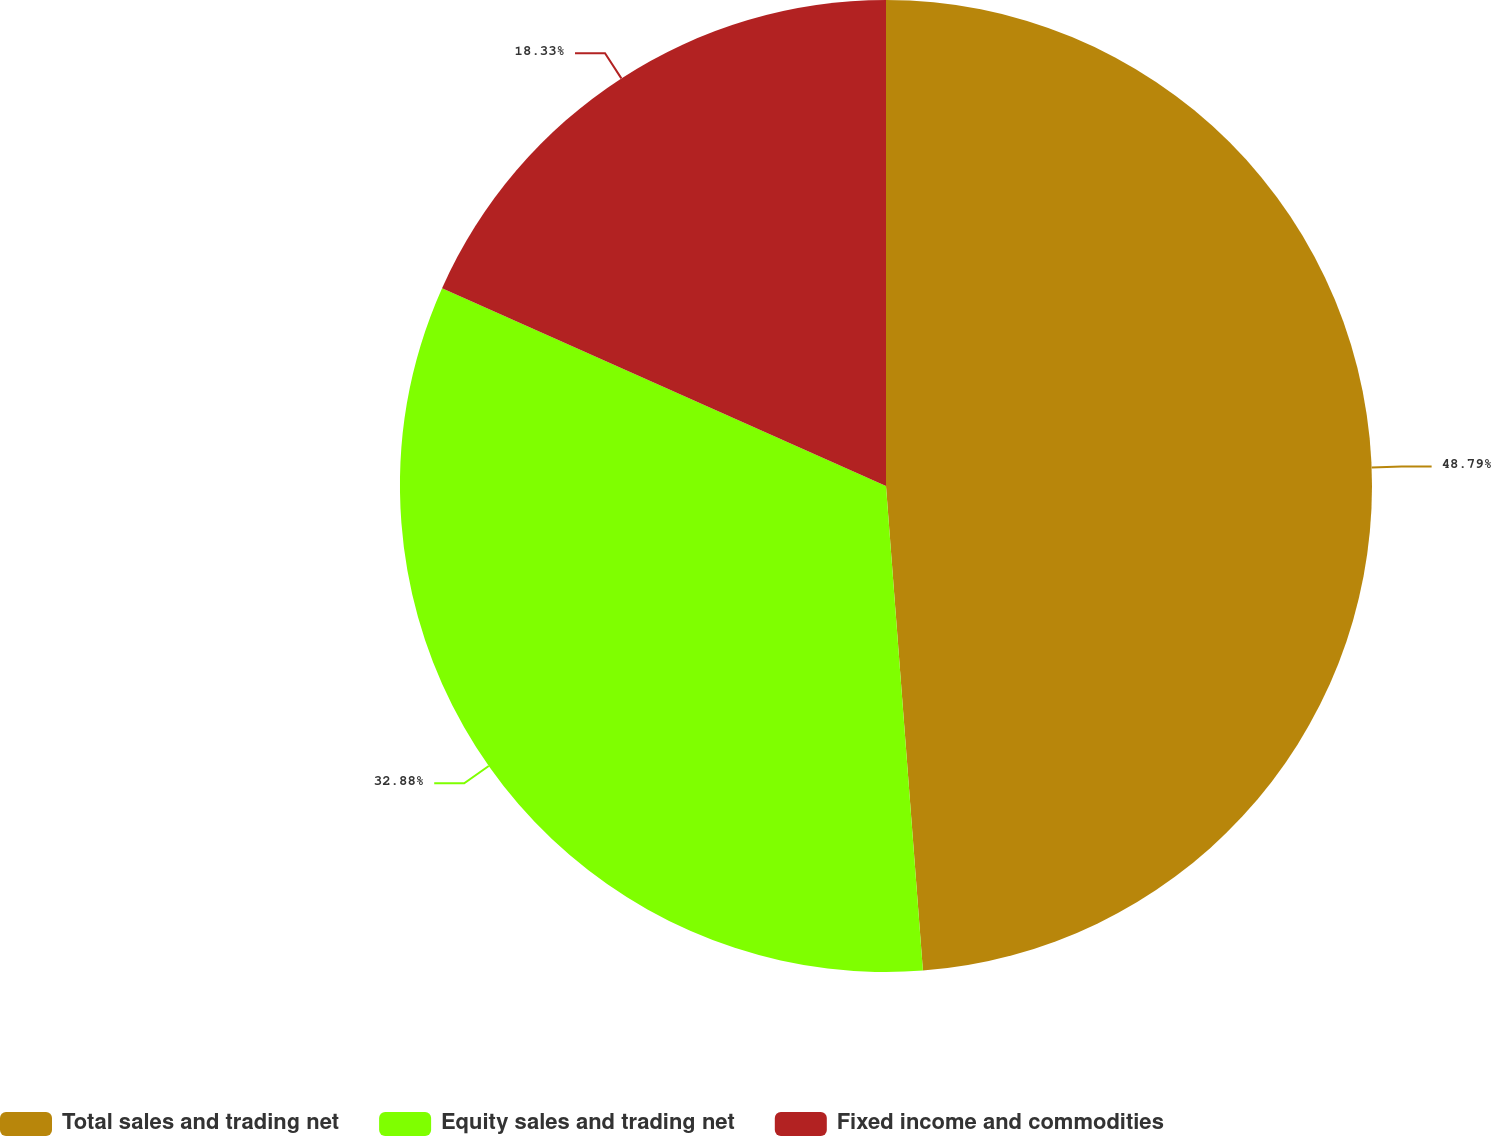Convert chart. <chart><loc_0><loc_0><loc_500><loc_500><pie_chart><fcel>Total sales and trading net<fcel>Equity sales and trading net<fcel>Fixed income and commodities<nl><fcel>48.79%<fcel>32.88%<fcel>18.33%<nl></chart> 